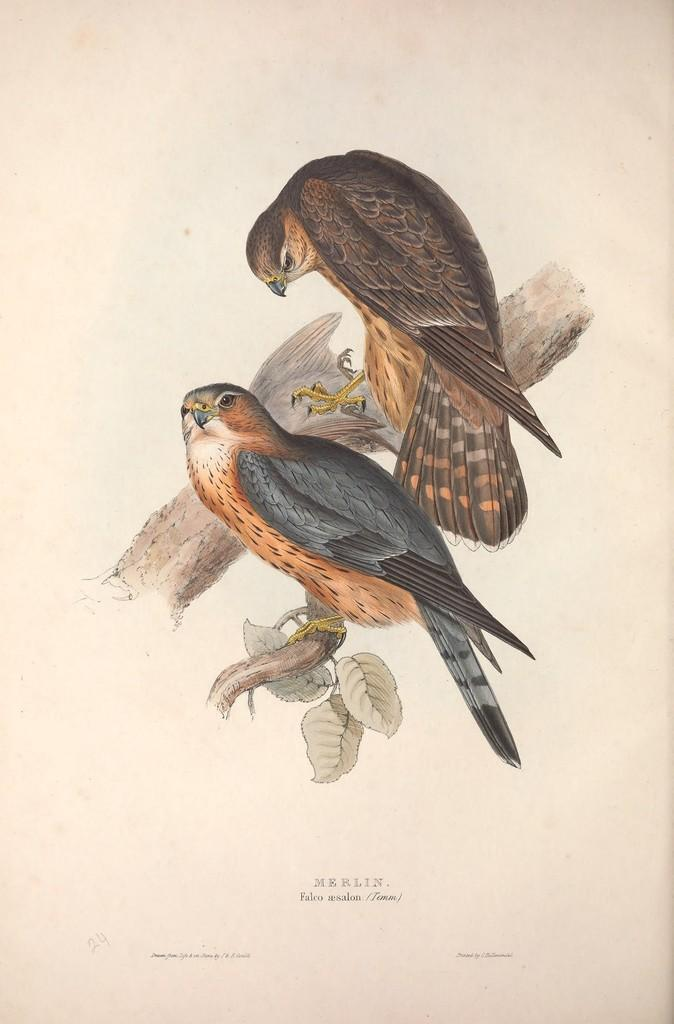What is the main subject of the image? There is an art piece in the image. What does the art piece depict? The art piece depicts two birds. What are the birds doing in the image? The birds are standing on a branch. How does the art piece express the feeling of regret in the image? The art piece does not express any feelings of regret, as it only depicts two birds standing on a branch. Can you tell me how many rabbits are present in the image? There are no rabbits present in the image; it only features two birds. 